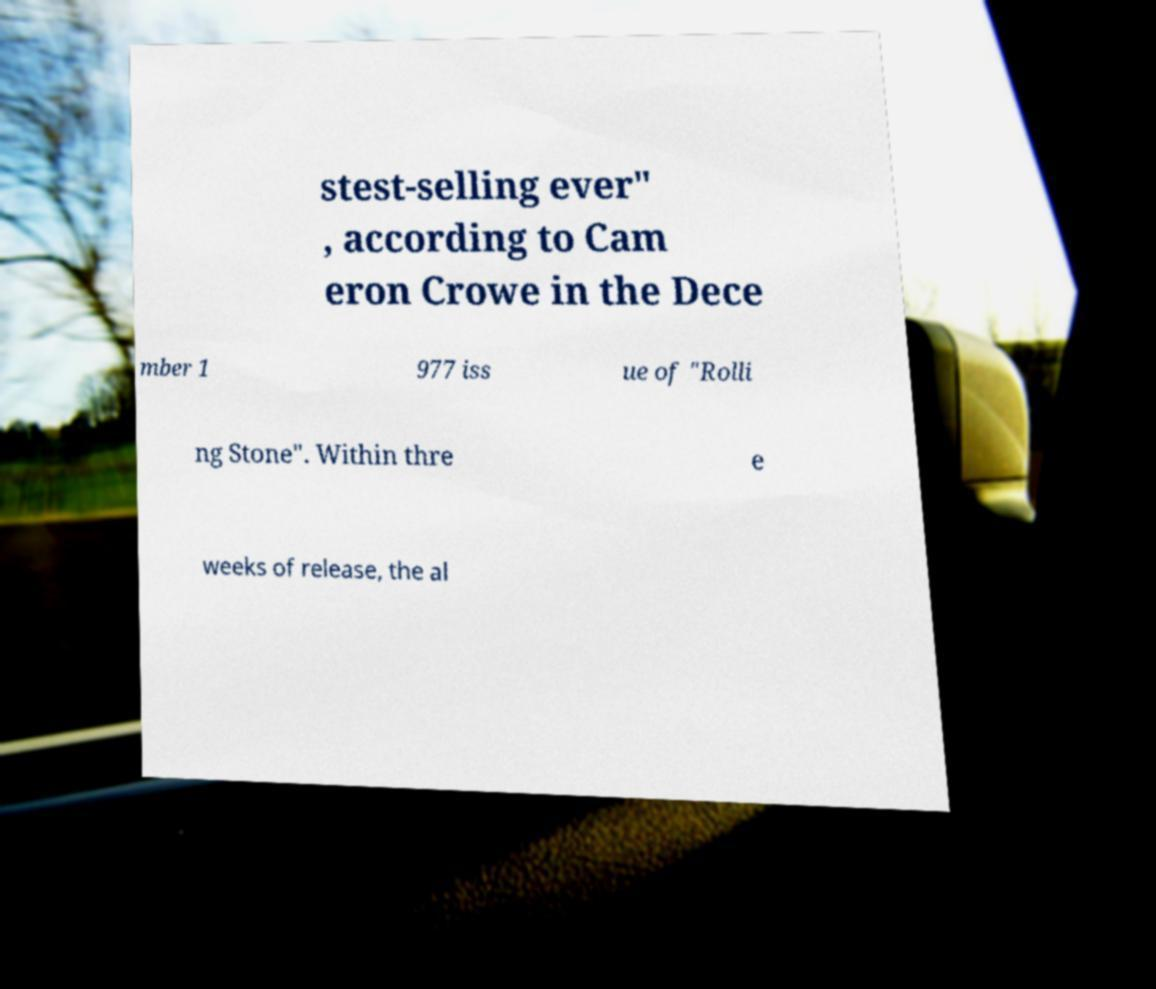What messages or text are displayed in this image? I need them in a readable, typed format. stest-selling ever" , according to Cam eron Crowe in the Dece mber 1 977 iss ue of "Rolli ng Stone". Within thre e weeks of release, the al 